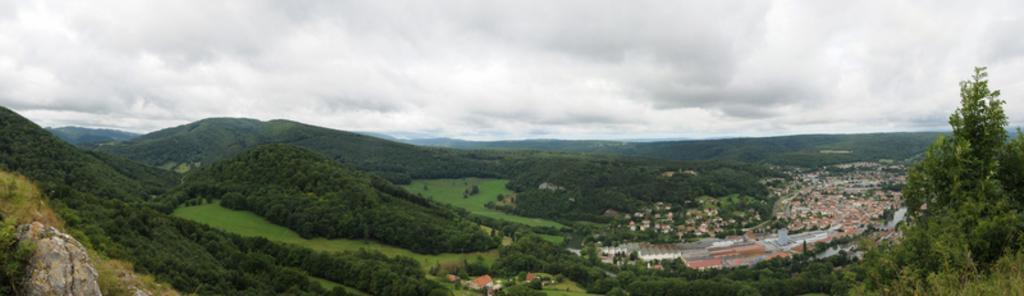Describe this image in one or two sentences. In this image I can see the buildings, many trees and the mountains. In the background I can see the clouds and the sky. 